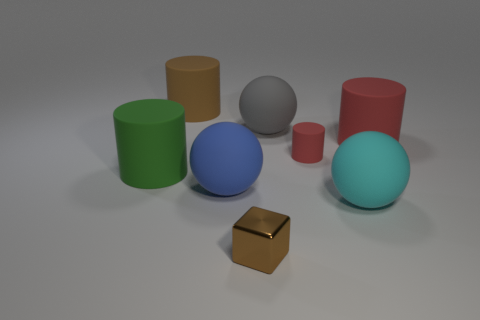If this image was part of a physics study on shapes and balance, what kind of question could be relevant? A relevant question might be, 'How do the different shapes affect the stability and balance of these objects when force is applied?' This could lead to an exploration of how spheres, which have no edges, may roll when pushed, while the stability of the cylinders and the block might vary based on their height and base area. 